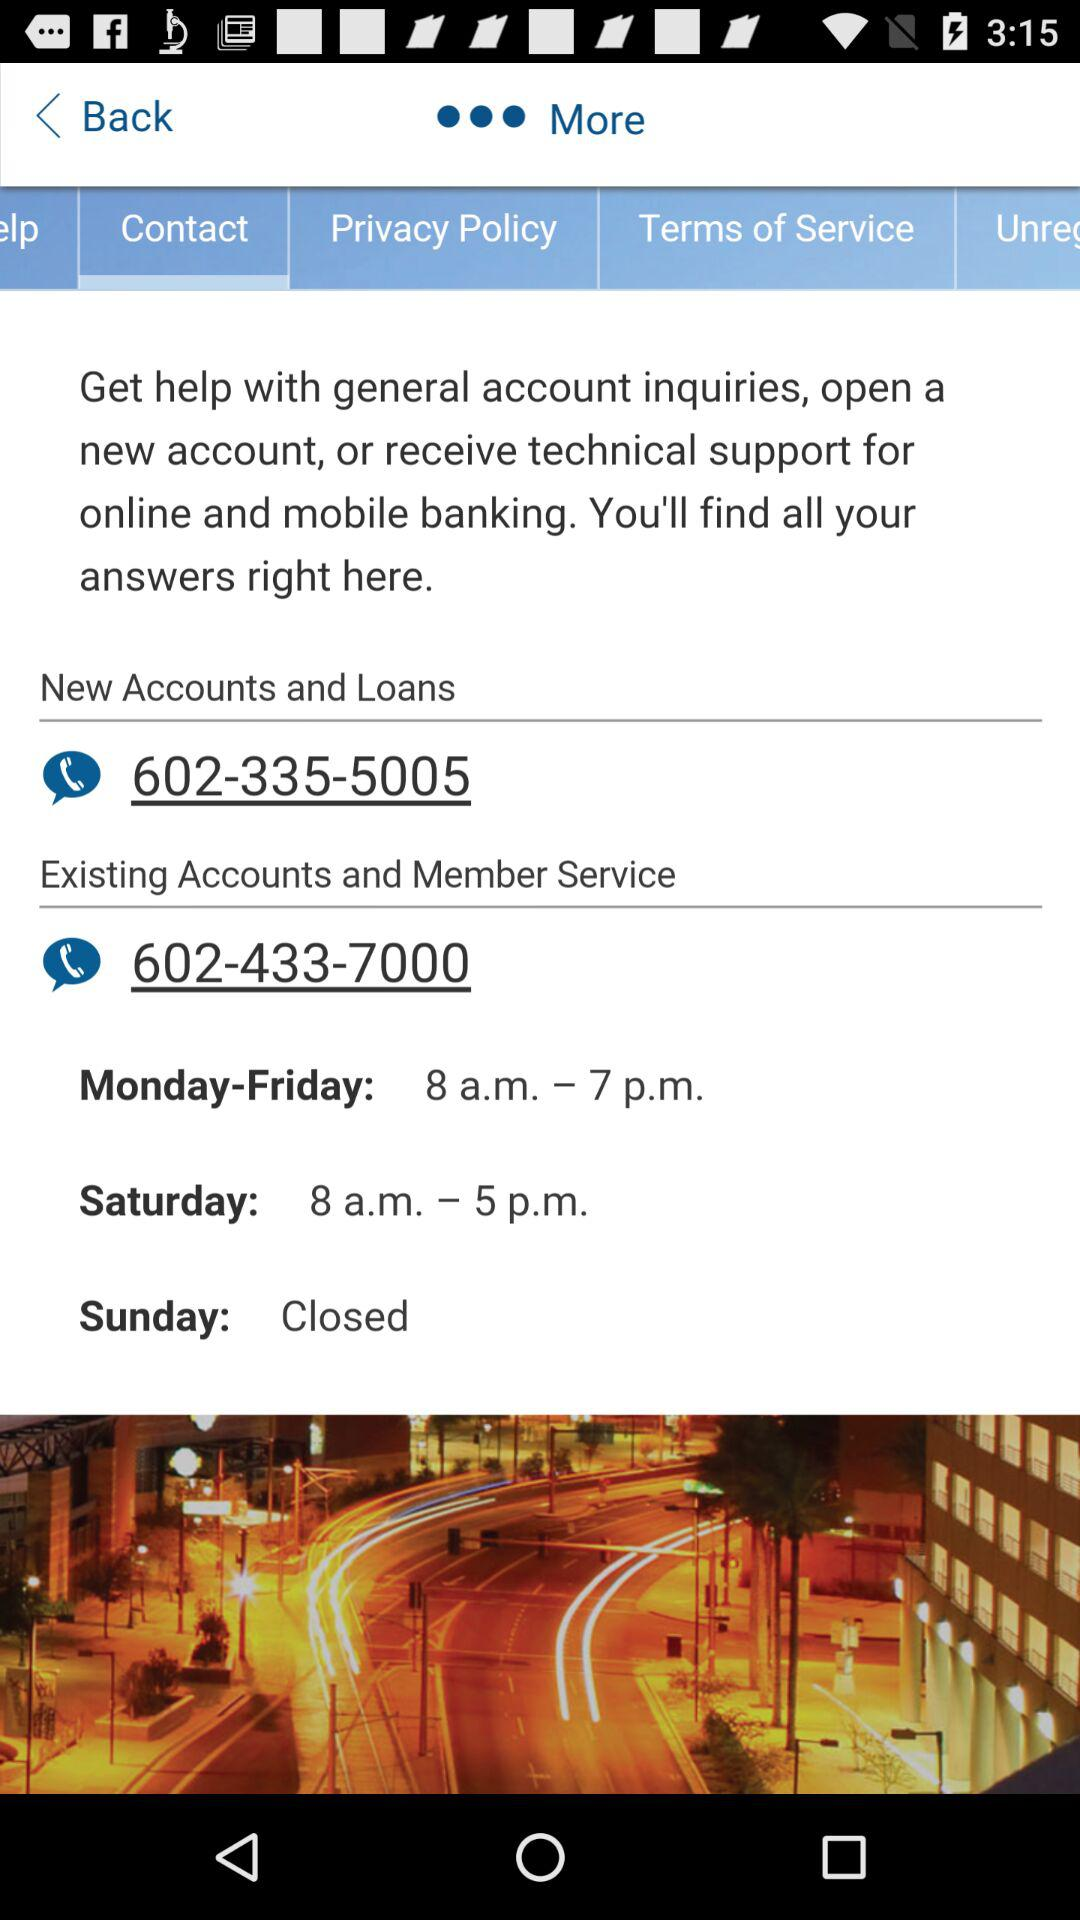What are the timings for Saturday? The timings for Saturday are 8 a.m. to 5 p.m. 